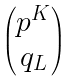Convert formula to latex. <formula><loc_0><loc_0><loc_500><loc_500>\begin{pmatrix} p ^ { K } \\ q _ { L } \end{pmatrix}</formula> 